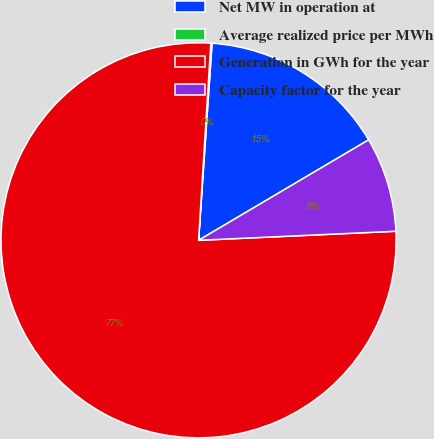Convert chart. <chart><loc_0><loc_0><loc_500><loc_500><pie_chart><fcel>Net MW in operation at<fcel>Average realized price per MWh<fcel>Generation in GWh for the year<fcel>Capacity factor for the year<nl><fcel>15.42%<fcel>0.1%<fcel>76.71%<fcel>7.76%<nl></chart> 